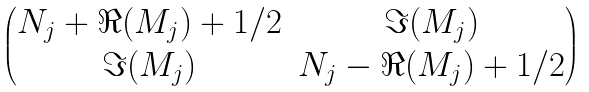<formula> <loc_0><loc_0><loc_500><loc_500>\begin{pmatrix} N _ { j } + \Re ( M _ { j } ) + 1 / 2 & \Im ( M _ { j } ) \\ \Im ( M _ { j } ) & N _ { j } - \Re ( M _ { j } ) + 1 / 2 \end{pmatrix}</formula> 